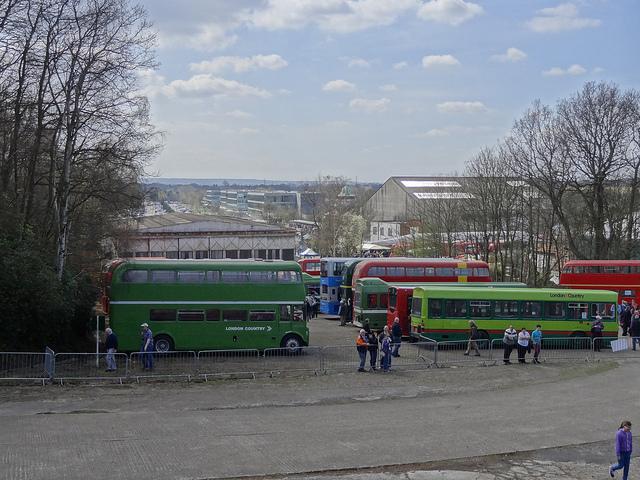What is used to fuel these vehicles?
Keep it brief. Gas. What colors are the front two busses?
Answer briefly. Green. Is the fence permanent?
Concise answer only. No. 